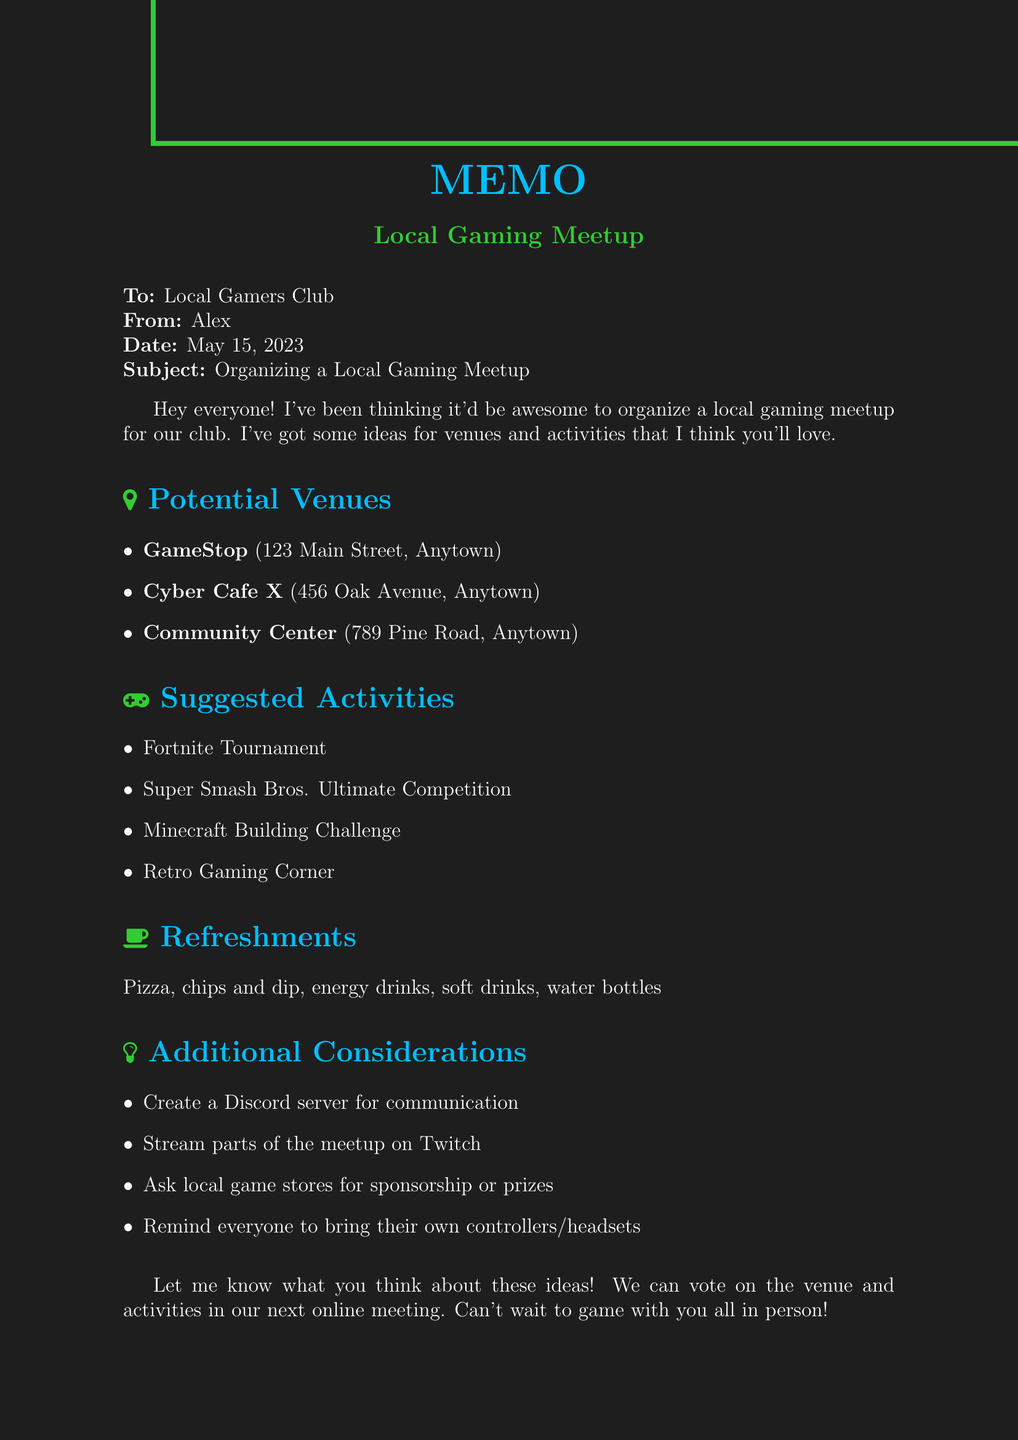what is the date of the memo? The date of the memo is clearly stated in the header section as May 15, 2023.
Answer: May 15, 2023 who is the sender of the memo? The sender of the memo is identified in the header section as Alex.
Answer: Alex what is one pro of using GameStop as a venue? One pro of using GameStop is listed as "Free to use their space".
Answer: Free to use their space how many activities are suggested in the document? The document lists a total of four suggested activities under the activities section.
Answer: Four which venue has an hourly rental fee? The venue that has an hourly rental fee is Cyber Cafe X, as mentioned in its cons.
Answer: Cyber Cafe X what refreshment is mentioned first in the list? The first refreshment mentioned in the list is Pizza.
Answer: Pizza what additional consideration suggests communication? The additional consideration that suggests communication is creating a Discord server for easy communication.
Answer: Create a Discord server for easy communication how will the venue and activities be decided? The venue and activities will be decided by voting in the next online meeting, as indicated in the conclusion.
Answer: Voting in the next online meeting 